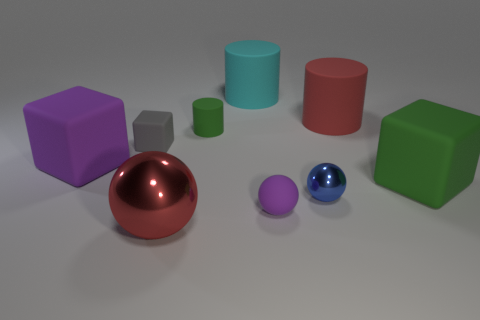What number of shiny objects are large green blocks or small balls?
Give a very brief answer. 1. There is a metal thing that is in front of the blue metal thing; is there a rubber object that is to the left of it?
Your answer should be compact. Yes. What number of objects are either green cubes that are on the right side of the tiny green cylinder or green things to the right of the cyan matte object?
Your answer should be compact. 1. Is there anything else that is the same color as the rubber ball?
Your answer should be very brief. Yes. The small rubber object that is in front of the big matte cube behind the green thing that is in front of the gray block is what color?
Give a very brief answer. Purple. There is a green rubber thing behind the big rubber cube to the left of the small green matte cylinder; what size is it?
Your answer should be compact. Small. What is the thing that is behind the tiny cylinder and on the right side of the large cyan rubber cylinder made of?
Your answer should be very brief. Rubber. There is a green matte block; is its size the same as the purple matte thing that is right of the tiny matte cube?
Give a very brief answer. No. Are there any big green matte things?
Make the answer very short. Yes. There is a small purple thing that is the same shape as the large red metallic object; what material is it?
Make the answer very short. Rubber. 